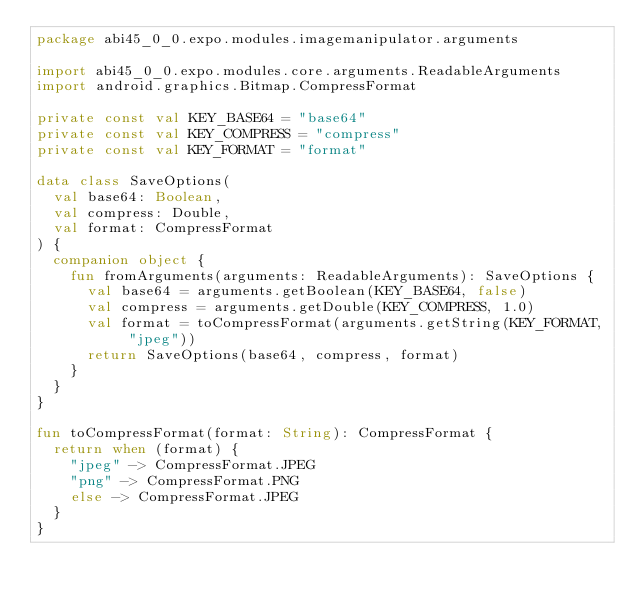Convert code to text. <code><loc_0><loc_0><loc_500><loc_500><_Kotlin_>package abi45_0_0.expo.modules.imagemanipulator.arguments

import abi45_0_0.expo.modules.core.arguments.ReadableArguments
import android.graphics.Bitmap.CompressFormat

private const val KEY_BASE64 = "base64"
private const val KEY_COMPRESS = "compress"
private const val KEY_FORMAT = "format"

data class SaveOptions(
  val base64: Boolean,
  val compress: Double,
  val format: CompressFormat
) {
  companion object {
    fun fromArguments(arguments: ReadableArguments): SaveOptions {
      val base64 = arguments.getBoolean(KEY_BASE64, false)
      val compress = arguments.getDouble(KEY_COMPRESS, 1.0)
      val format = toCompressFormat(arguments.getString(KEY_FORMAT, "jpeg"))
      return SaveOptions(base64, compress, format)
    }
  }
}

fun toCompressFormat(format: String): CompressFormat {
  return when (format) {
    "jpeg" -> CompressFormat.JPEG
    "png" -> CompressFormat.PNG
    else -> CompressFormat.JPEG
  }
}
</code> 